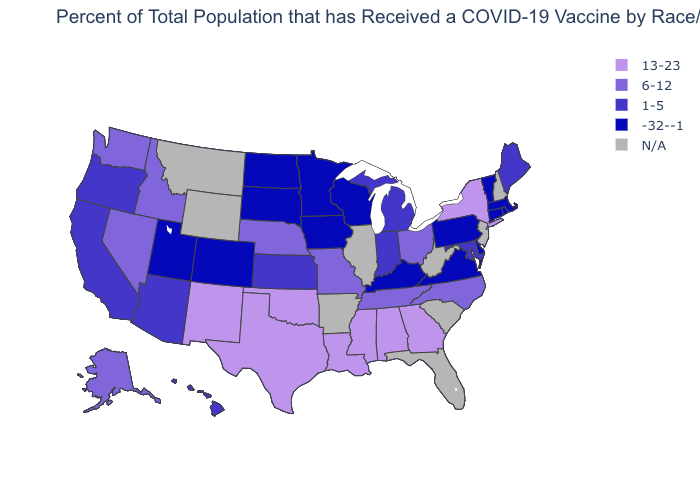Name the states that have a value in the range N/A?
Write a very short answer. Arkansas, Florida, Illinois, Montana, New Hampshire, New Jersey, South Carolina, West Virginia, Wyoming. What is the value of Maine?
Concise answer only. 1-5. Name the states that have a value in the range 1-5?
Keep it brief. Arizona, California, Hawaii, Indiana, Kansas, Maine, Maryland, Michigan, Oregon. What is the value of Oregon?
Write a very short answer. 1-5. How many symbols are there in the legend?
Quick response, please. 5. Which states have the lowest value in the West?
Short answer required. Colorado, Utah. Among the states that border Michigan , does Wisconsin have the lowest value?
Answer briefly. Yes. Name the states that have a value in the range 1-5?
Be succinct. Arizona, California, Hawaii, Indiana, Kansas, Maine, Maryland, Michigan, Oregon. Which states hav the highest value in the Northeast?
Short answer required. New York. What is the value of Georgia?
Short answer required. 13-23. Which states have the highest value in the USA?
Quick response, please. Alabama, Georgia, Louisiana, Mississippi, New Mexico, New York, Oklahoma, Texas. 